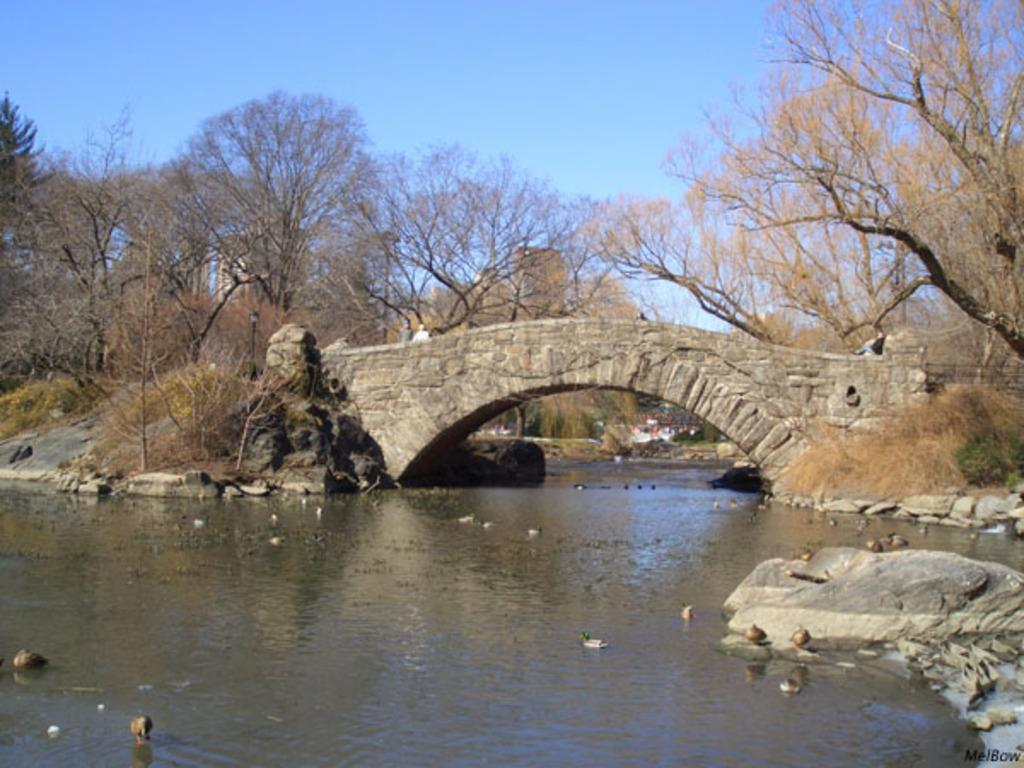What is the primary element present in the image? There is water in the image. What type of animals can be seen in the image? Birds can be seen in the image. What natural features are present in the image? There are rocks and trees in the image. Are there any human figures in the image? Yes, there are persons in the image. What type of structure is visible in the image? There is a bridge in the image. What can be seen in the background of the image? The sky is visible in the background of the image. What type of finger can be seen pointing at the moon in the image? There is no finger or moon present in the image. In which bedroom can the persons be seen in the image? The image does not depict a bedroom; it shows a scene with water, birds, rocks, trees, persons, a bridge, and the sky. 